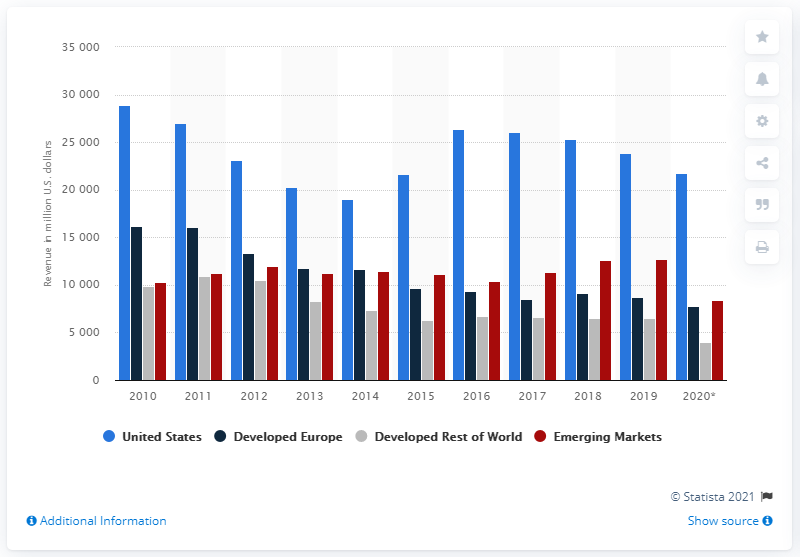Mention a couple of crucial points in this snapshot. Pfizer's total revenue in 2020 was primarily generated from sales in the United States, which contributed approximately 21,704 million dollars to the company's total revenue. 